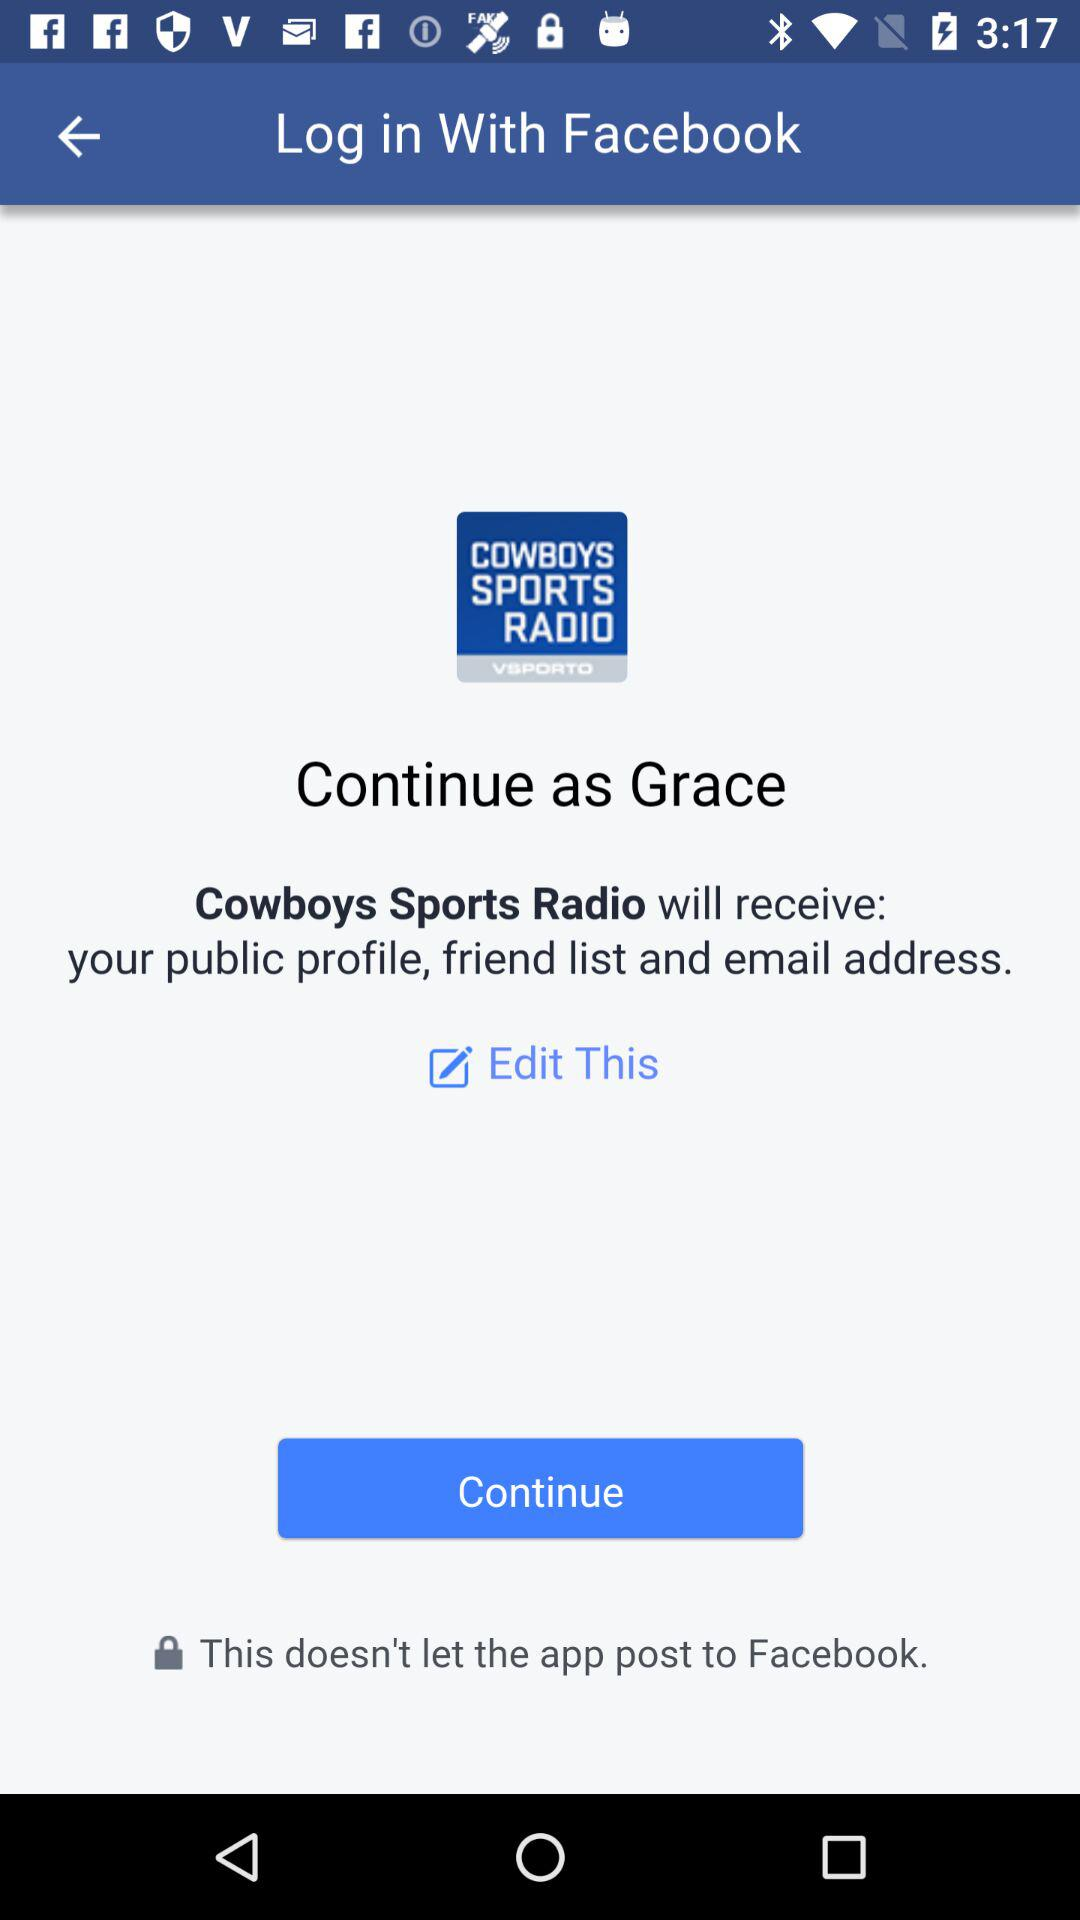What applications can be used to log in to a profile? The application that can be used to log in to a profile is "Facebook". 